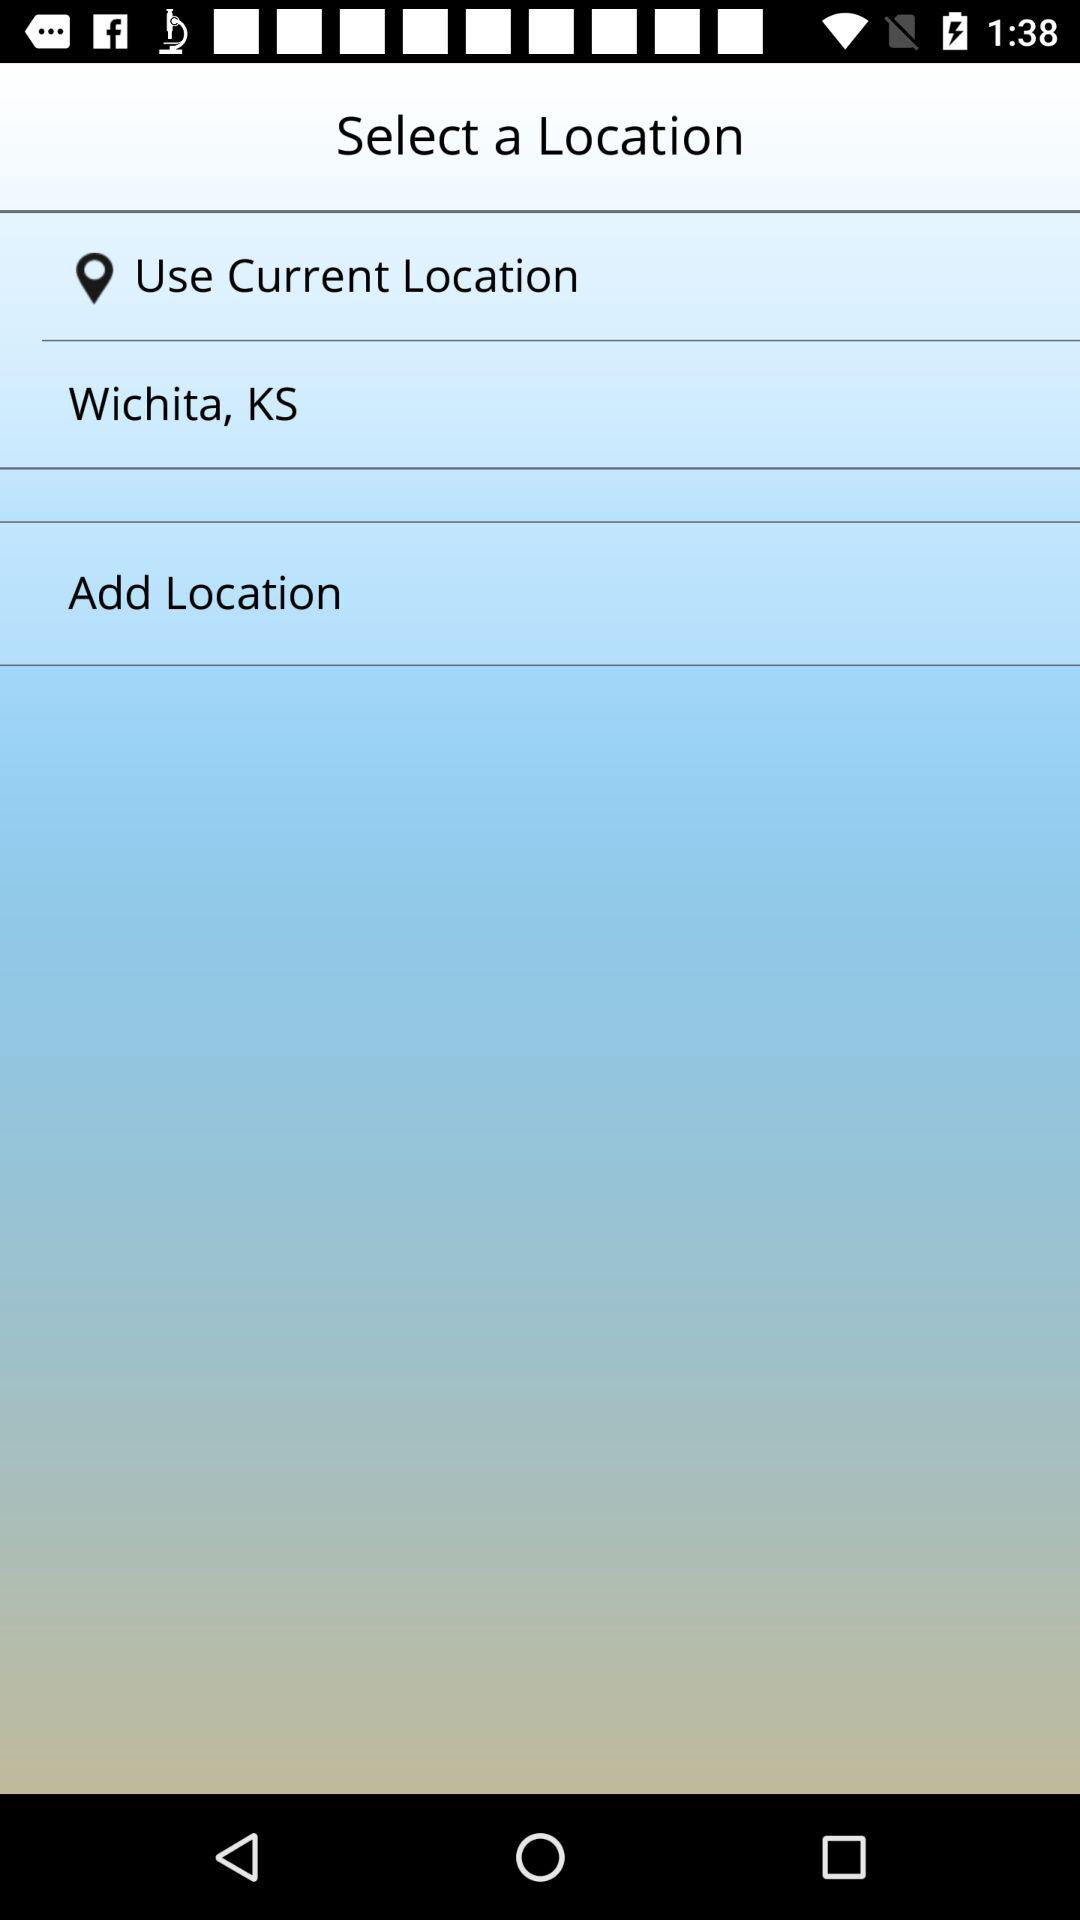How many locations are there to select from?
Answer the question using a single word or phrase. 2 